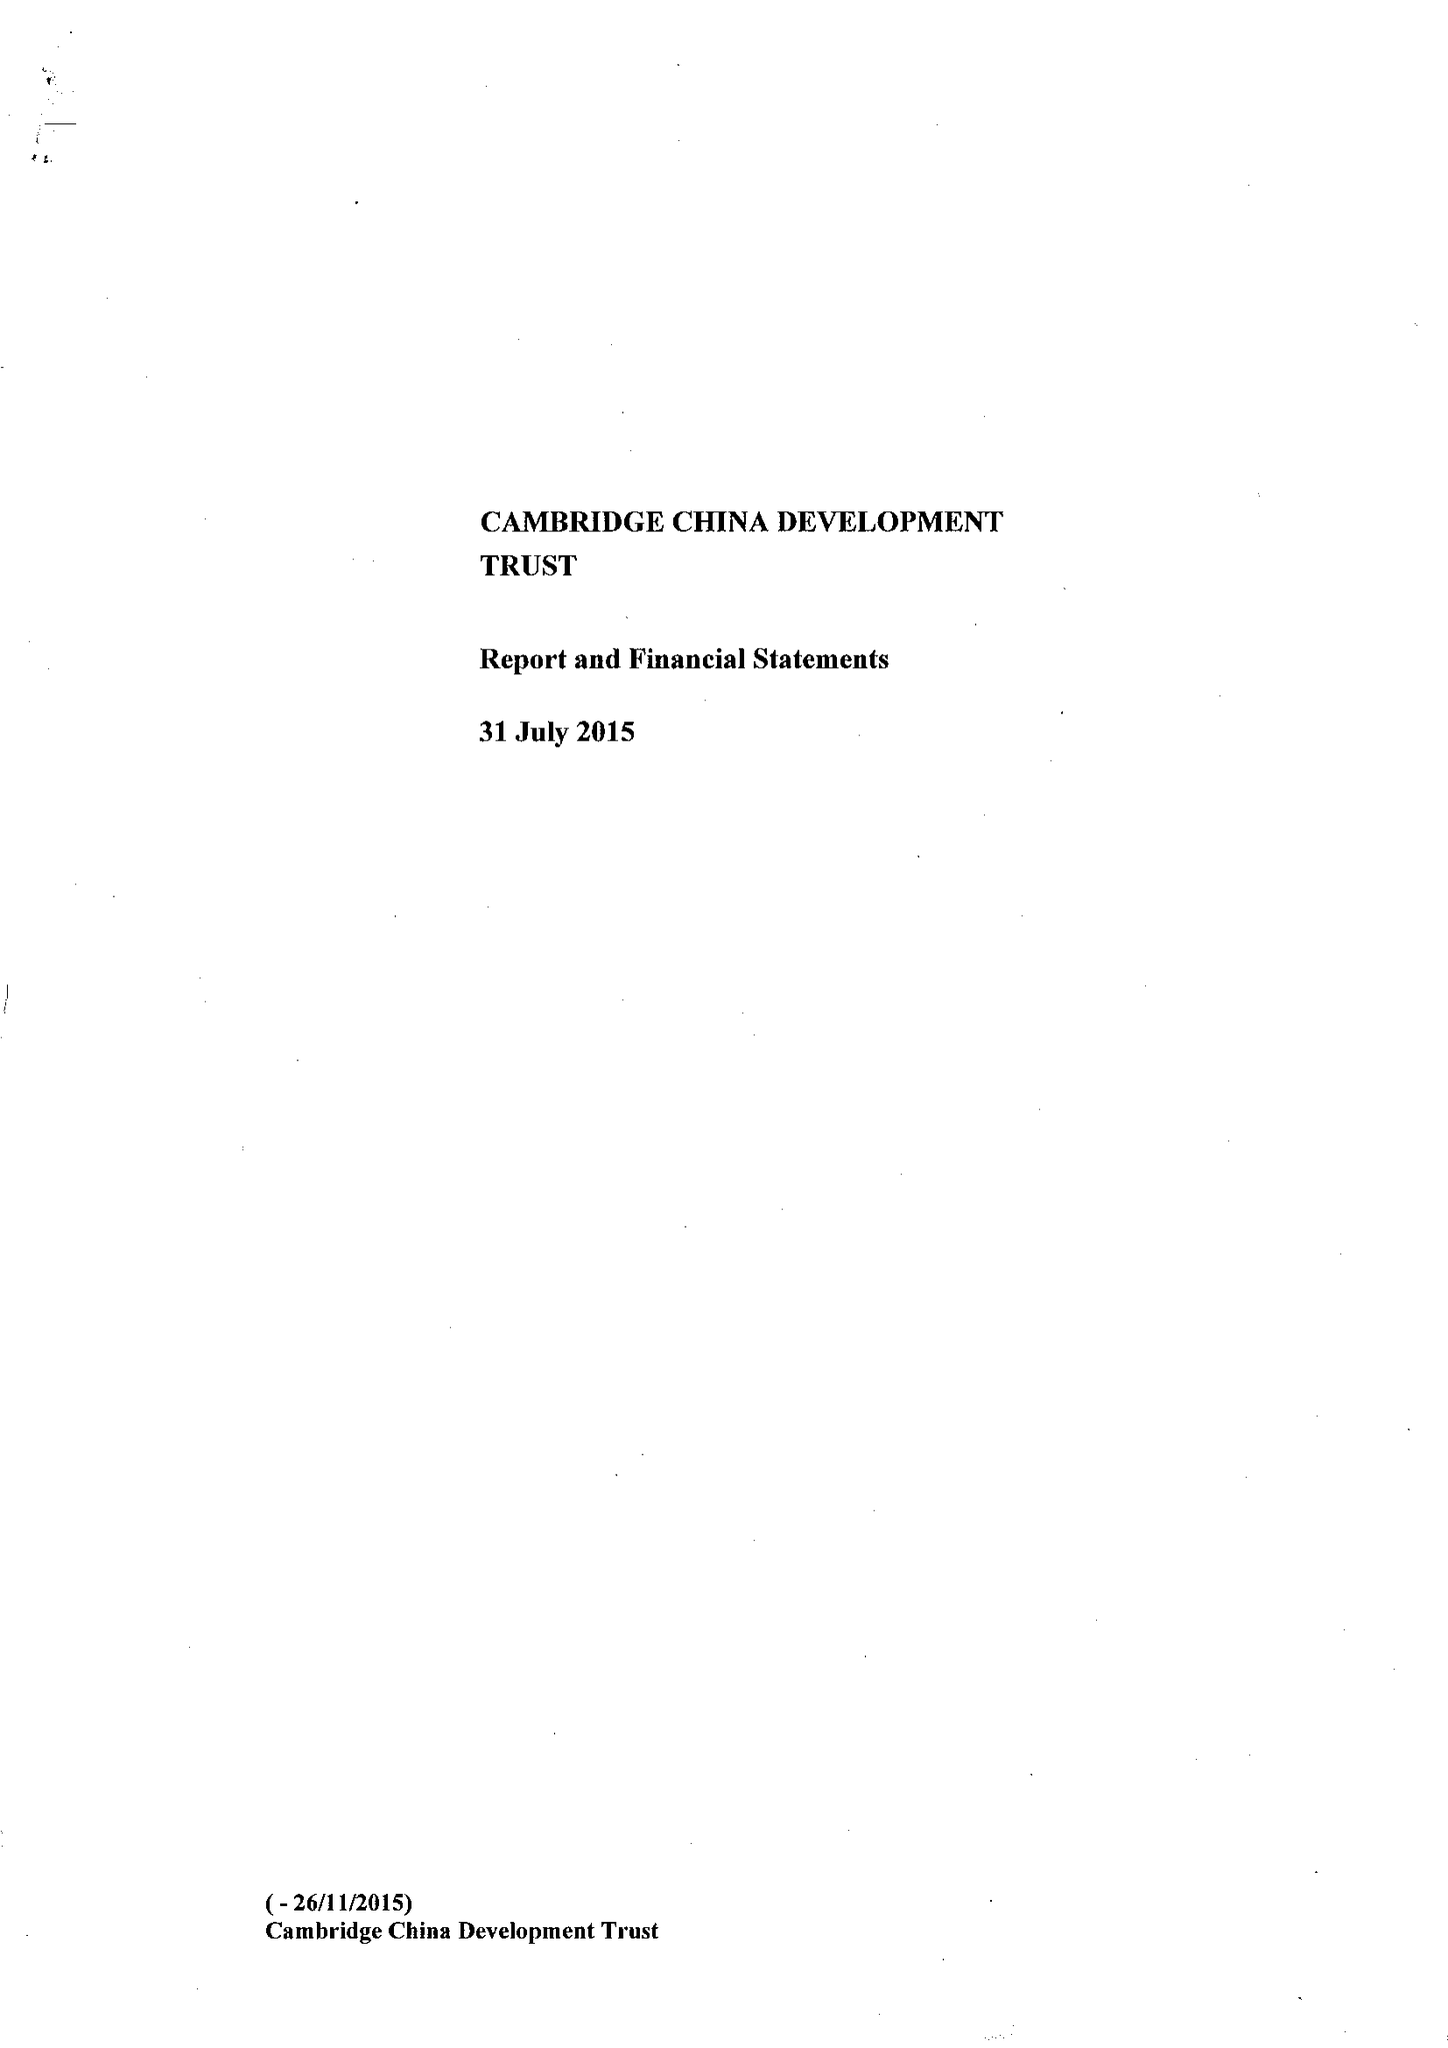What is the value for the spending_annually_in_british_pounds?
Answer the question using a single word or phrase. 354798.00 